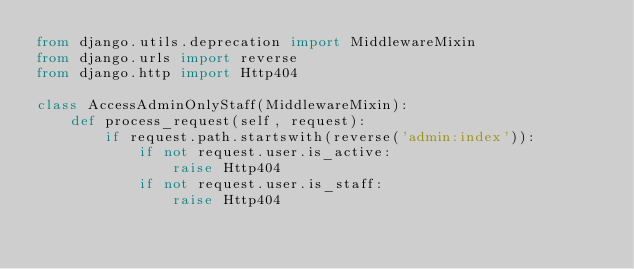<code> <loc_0><loc_0><loc_500><loc_500><_Python_>from django.utils.deprecation import MiddlewareMixin
from django.urls import reverse
from django.http import Http404

class AccessAdminOnlyStaff(MiddlewareMixin):
    def process_request(self, request):
        if request.path.startswith(reverse('admin:index')):
            if not request.user.is_active:
                raise Http404
            if not request.user.is_staff:
                raise Http404
</code> 